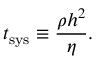Convert formula to latex. <formula><loc_0><loc_0><loc_500><loc_500>t _ { s y s } \equiv \frac { \rho h ^ { 2 } } { \eta } .</formula> 